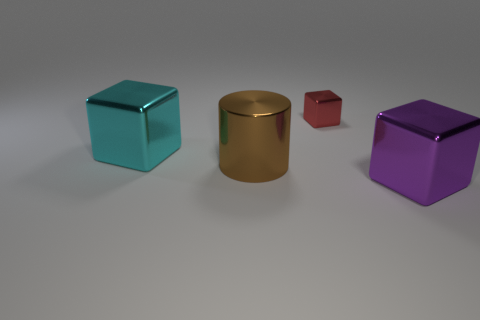Is there anything in the image that indicates the size of these objects? There are no direct references for scale in the image like a coin or a ruler, but the shadows and lighting can give an impression of size relative to each other. 